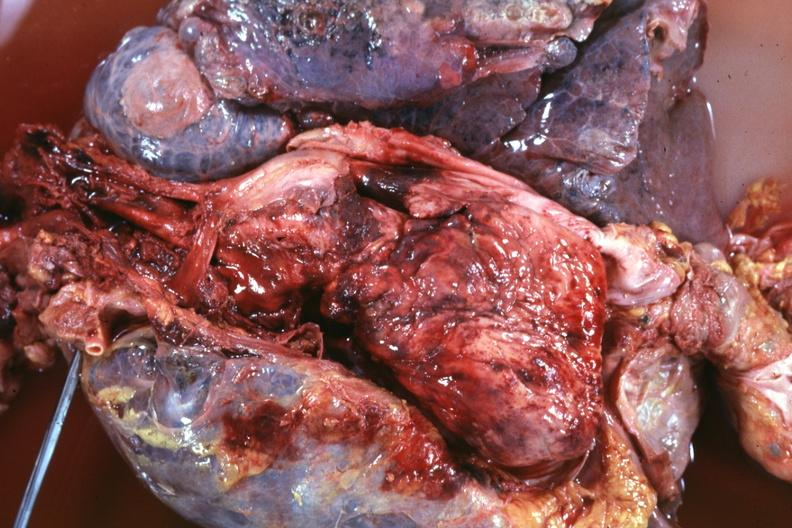what dissected to show super cava and region of tumor invasion quite good?
Answer the question using a single word or phrase. Thoracic organs 